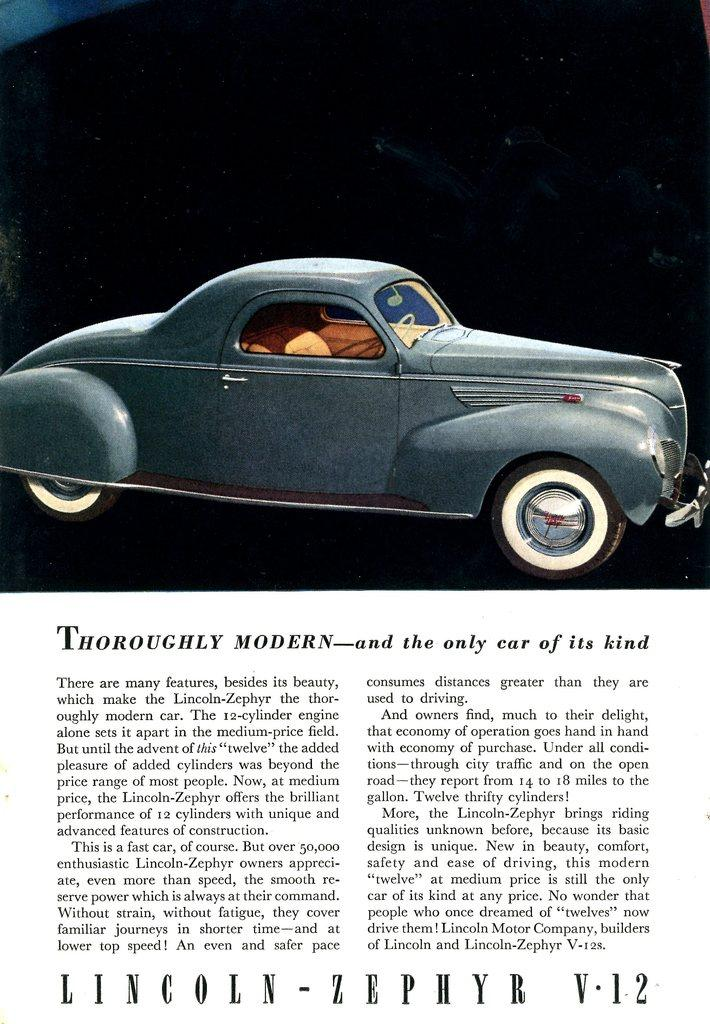What is present on the paper in the image? There is writing on the paper in the image. What else can be seen in the image besides the paper? There is a grey color car in the image. Who is the owner of the sponge in the image? There is no sponge present in the image. What type of comb is being used by the person in the image? There is no person or comb present in the image. 